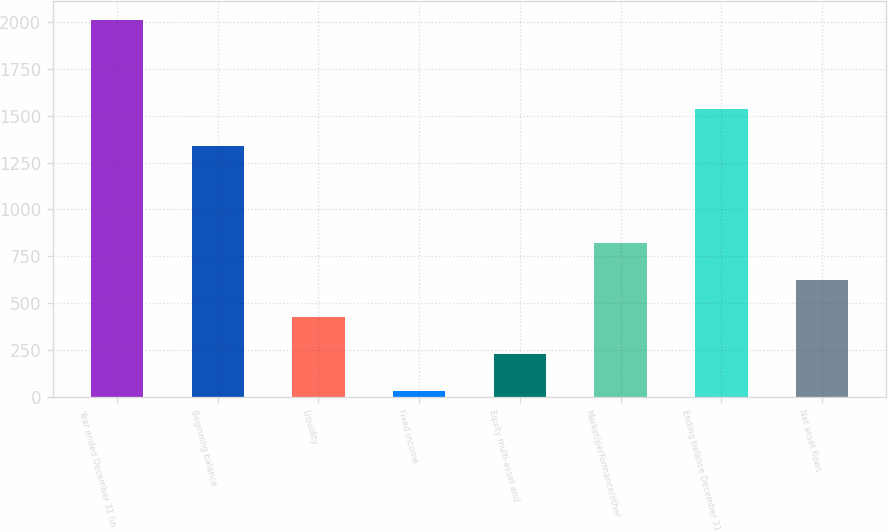<chart> <loc_0><loc_0><loc_500><loc_500><bar_chart><fcel>Year ended December 31 (in<fcel>Beginning balance<fcel>Liquidity<fcel>Fixed income<fcel>Equity multi-asset and<fcel>Market/performance/other<fcel>Ending balance December 31<fcel>Net asset flows<nl><fcel>2012<fcel>1336<fcel>426.4<fcel>30<fcel>228.2<fcel>822.8<fcel>1534.2<fcel>624.6<nl></chart> 